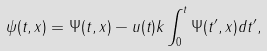Convert formula to latex. <formula><loc_0><loc_0><loc_500><loc_500>\psi ( t , x ) = \Psi ( t , x ) - u ( t ) k \int ^ { t } _ { 0 } \Psi ( t ^ { \prime } , x ) d t ^ { \prime } ,</formula> 